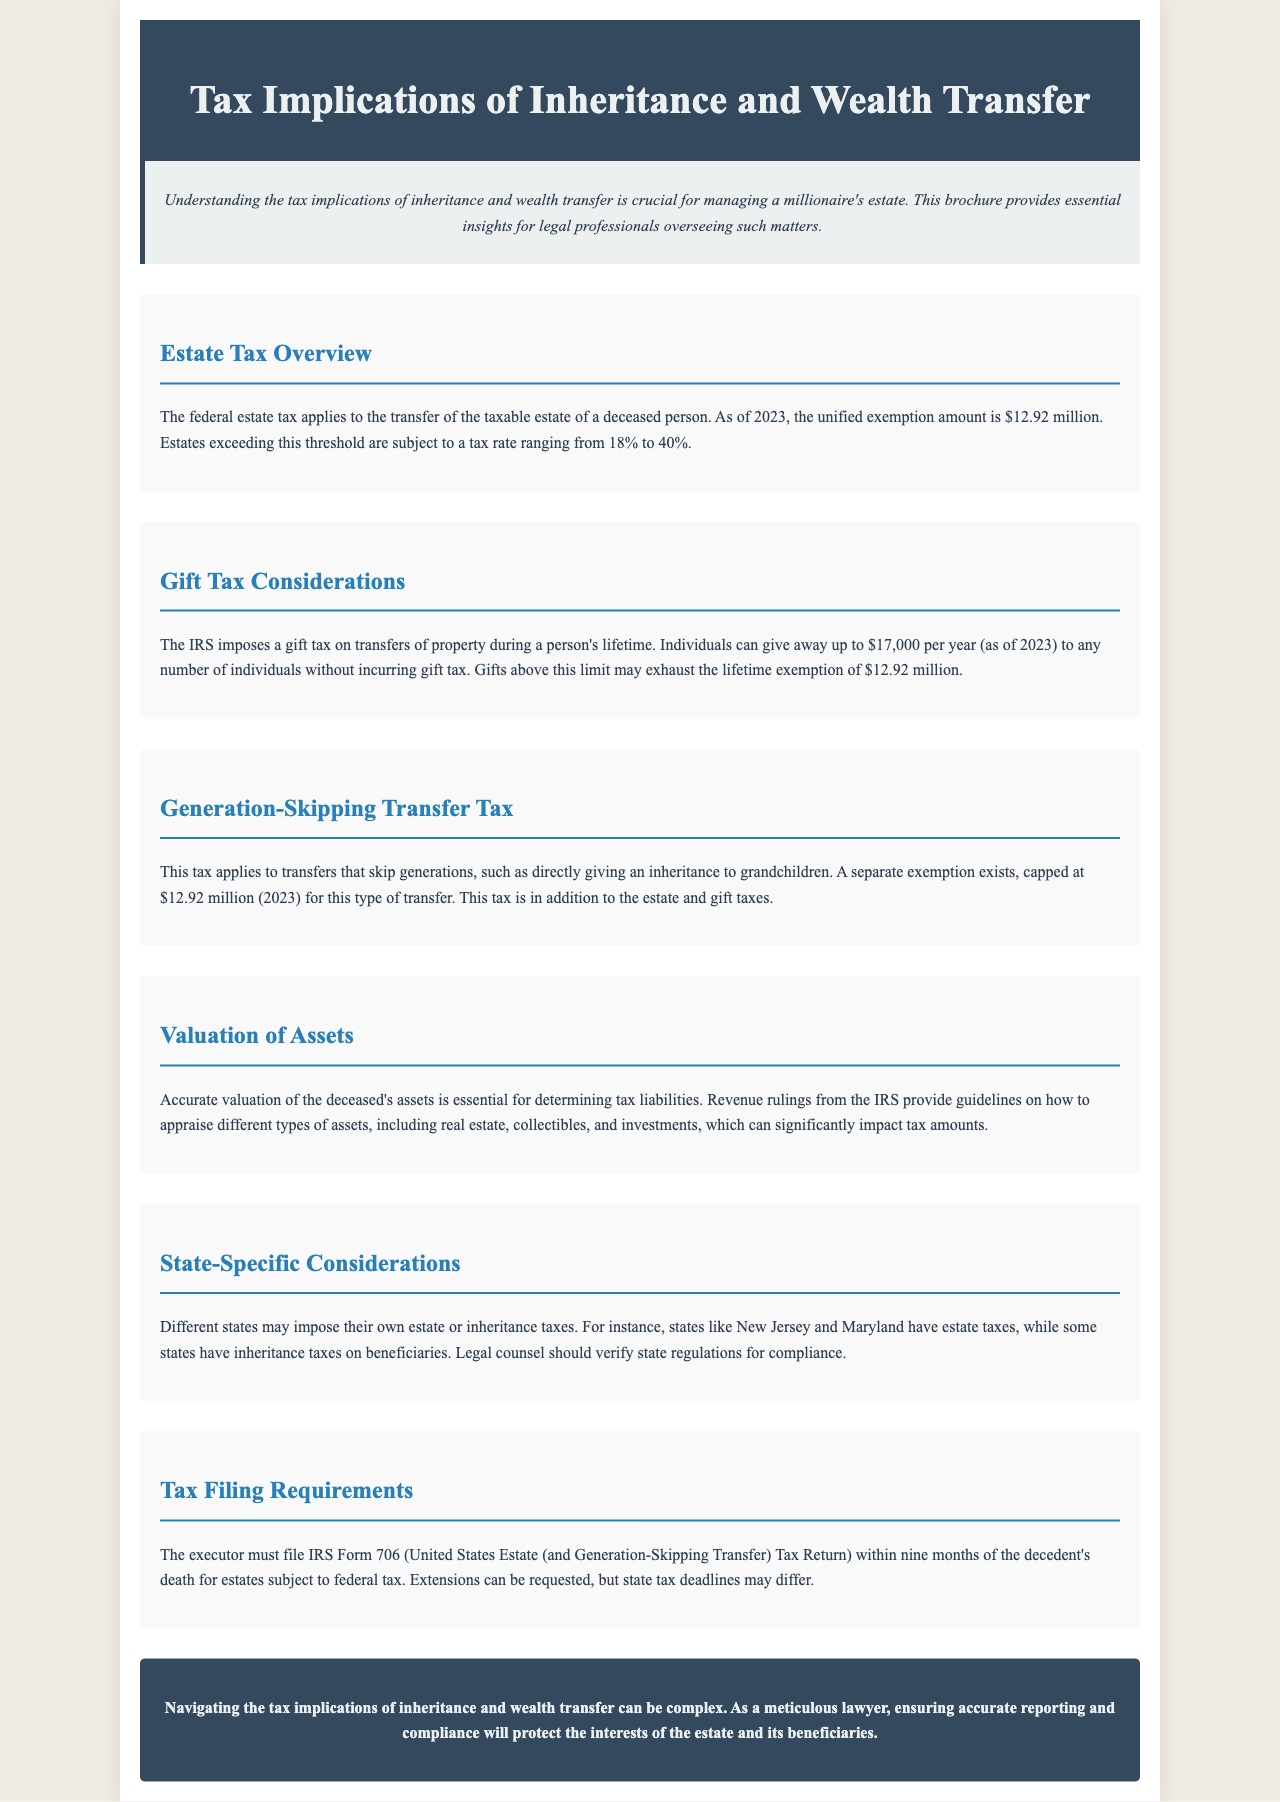What is the federal estate tax exemption amount for 2023? The document states that as of 2023, the unified exemption amount is $12.92 million.
Answer: $12.92 million What is the gift tax exclusion amount per year per individual in 2023? According to the brochure, individuals can give away up to $17,000 per year to any number of individuals without incurring gift tax.
Answer: $17,000 What is the tax rate range for estates exceeding the exemption amount? The text indicates that estates exceeding this threshold are subject to a tax rate ranging from 18% to 40%.
Answer: 18% to 40% What is the separate exemption for generation-skipping transfers in 2023? The brochure mentions that there is a separate exemption for this type of transfer, capped at $12.92 million in 2023.
Answer: $12.92 million Which states are mentioned as having estate taxes? The document specifies that states like New Jersey and Maryland have estate taxes.
Answer: New Jersey and Maryland What form must the executor file for estates subject to federal tax? The text indicates that the executor must file IRS Form 706 for federal tax.
Answer: IRS Form 706 Why is accurate valuation of assets important? The document explains that accurate valuation is essential for determining tax liabilities, impacting tax amounts significantly.
Answer: For determining tax liabilities What is a key responsibility of a meticulous lawyer managing an estate? The conclusion emphasizes that a key responsibility is ensuring accurate reporting and compliance to protect the interests of the estate and its beneficiaries.
Answer: Ensuring accurate reporting and compliance 